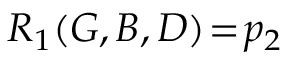Convert formula to latex. <formula><loc_0><loc_0><loc_500><loc_500>R _ { 1 } ( G , B , D ) \, = \, p _ { 2 }</formula> 